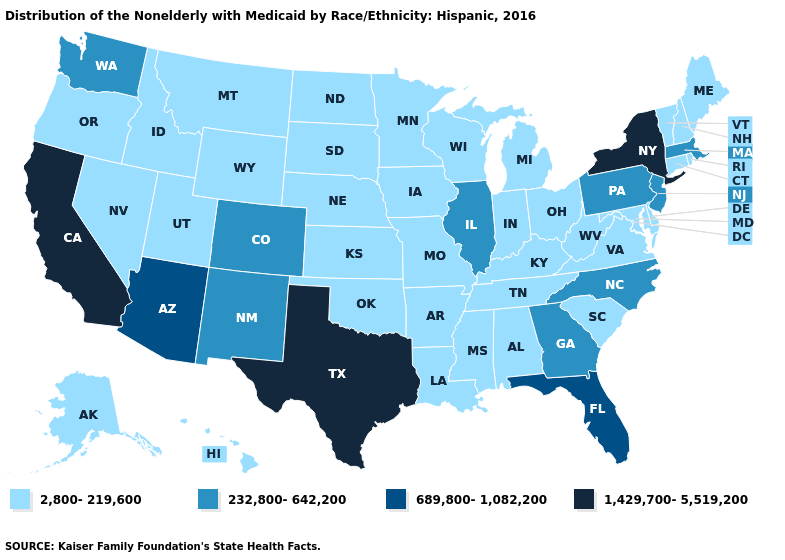What is the highest value in the West ?
Give a very brief answer. 1,429,700-5,519,200. Does the map have missing data?
Short answer required. No. What is the highest value in the South ?
Write a very short answer. 1,429,700-5,519,200. Which states have the lowest value in the MidWest?
Keep it brief. Indiana, Iowa, Kansas, Michigan, Minnesota, Missouri, Nebraska, North Dakota, Ohio, South Dakota, Wisconsin. Does New Hampshire have the highest value in the Northeast?
Give a very brief answer. No. Which states have the lowest value in the West?
Give a very brief answer. Alaska, Hawaii, Idaho, Montana, Nevada, Oregon, Utah, Wyoming. What is the value of Rhode Island?
Concise answer only. 2,800-219,600. Does the map have missing data?
Quick response, please. No. What is the lowest value in the USA?
Write a very short answer. 2,800-219,600. What is the value of New Jersey?
Short answer required. 232,800-642,200. Which states have the highest value in the USA?
Concise answer only. California, New York, Texas. Name the states that have a value in the range 1,429,700-5,519,200?
Keep it brief. California, New York, Texas. Name the states that have a value in the range 1,429,700-5,519,200?
Concise answer only. California, New York, Texas. 